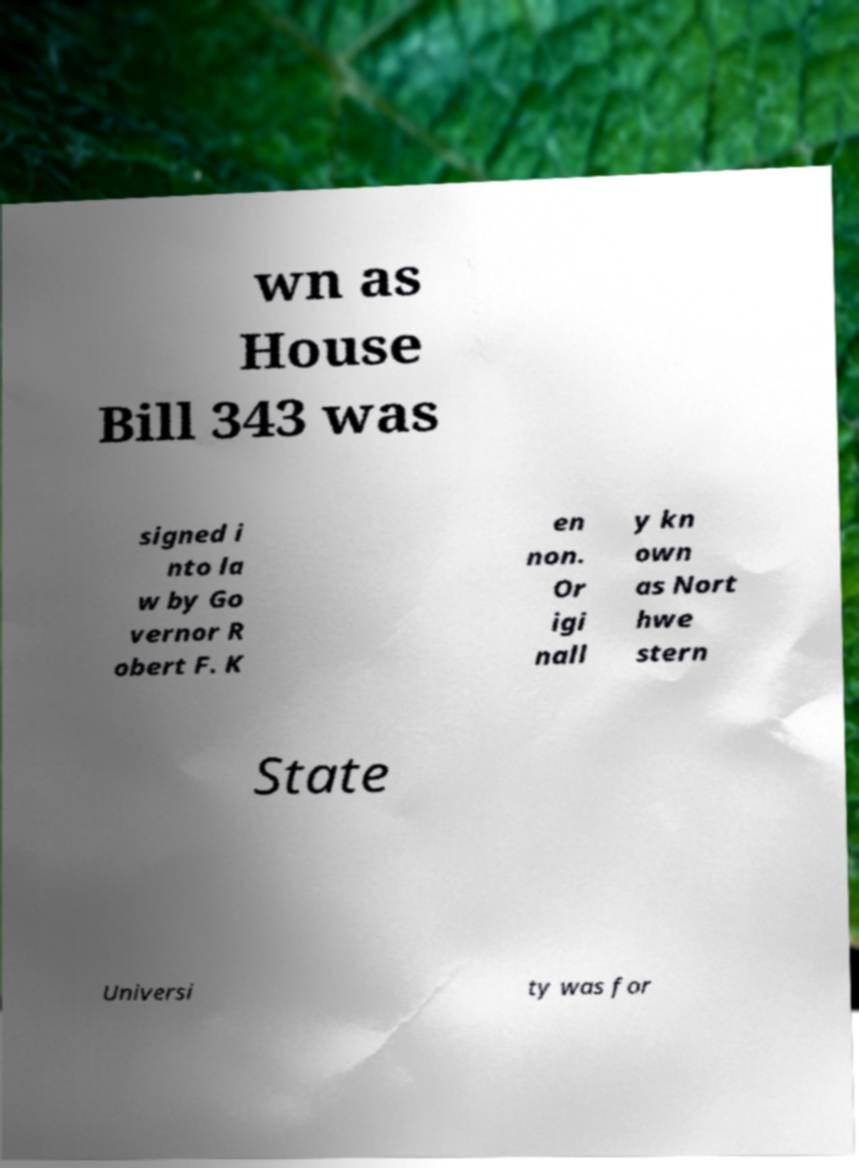Can you read and provide the text displayed in the image?This photo seems to have some interesting text. Can you extract and type it out for me? wn as House Bill 343 was signed i nto la w by Go vernor R obert F. K en non. Or igi nall y kn own as Nort hwe stern State Universi ty was for 